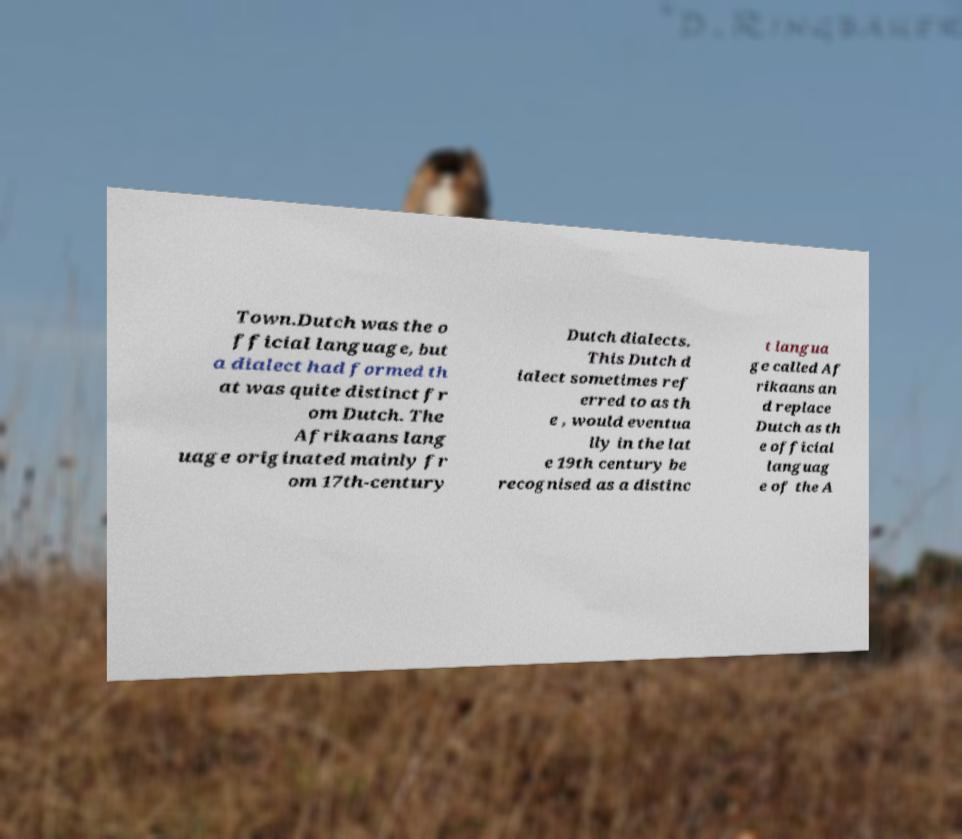Can you accurately transcribe the text from the provided image for me? Town.Dutch was the o fficial language, but a dialect had formed th at was quite distinct fr om Dutch. The Afrikaans lang uage originated mainly fr om 17th-century Dutch dialects. This Dutch d ialect sometimes ref erred to as th e , would eventua lly in the lat e 19th century be recognised as a distinc t langua ge called Af rikaans an d replace Dutch as th e official languag e of the A 